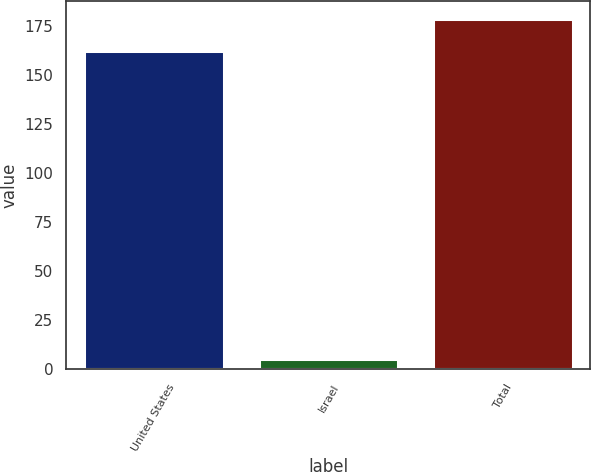Convert chart. <chart><loc_0><loc_0><loc_500><loc_500><bar_chart><fcel>United States<fcel>Israel<fcel>Total<nl><fcel>162<fcel>5<fcel>178.6<nl></chart> 